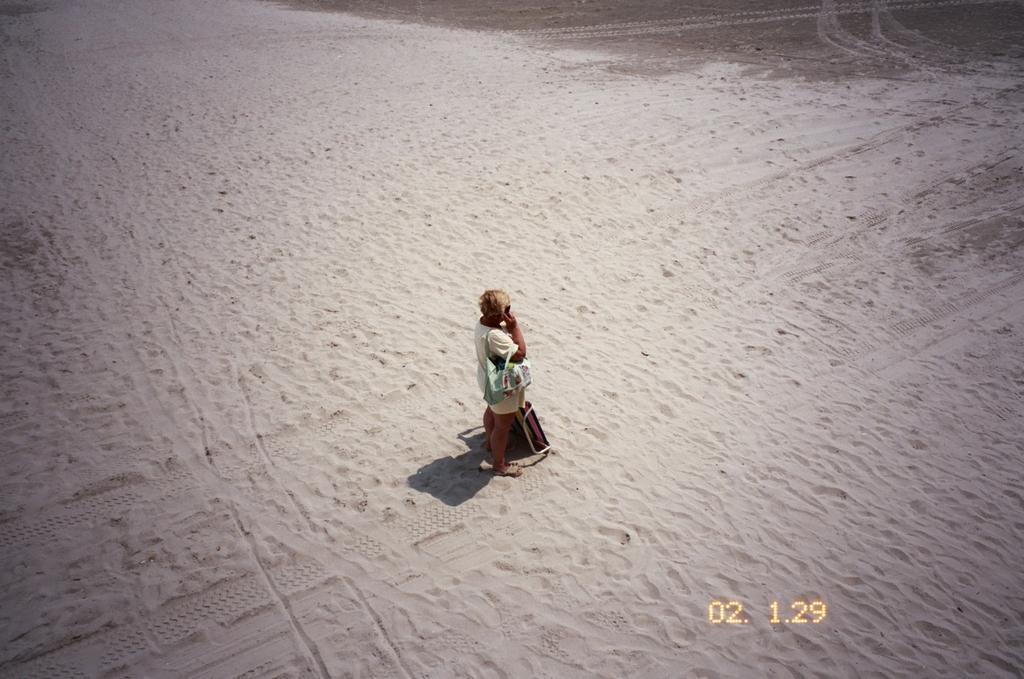In one or two sentences, can you explain what this image depicts? In the center of the image, we can see a person wearing a bag and holding an object and we can see an object on the sand and there is some text. 